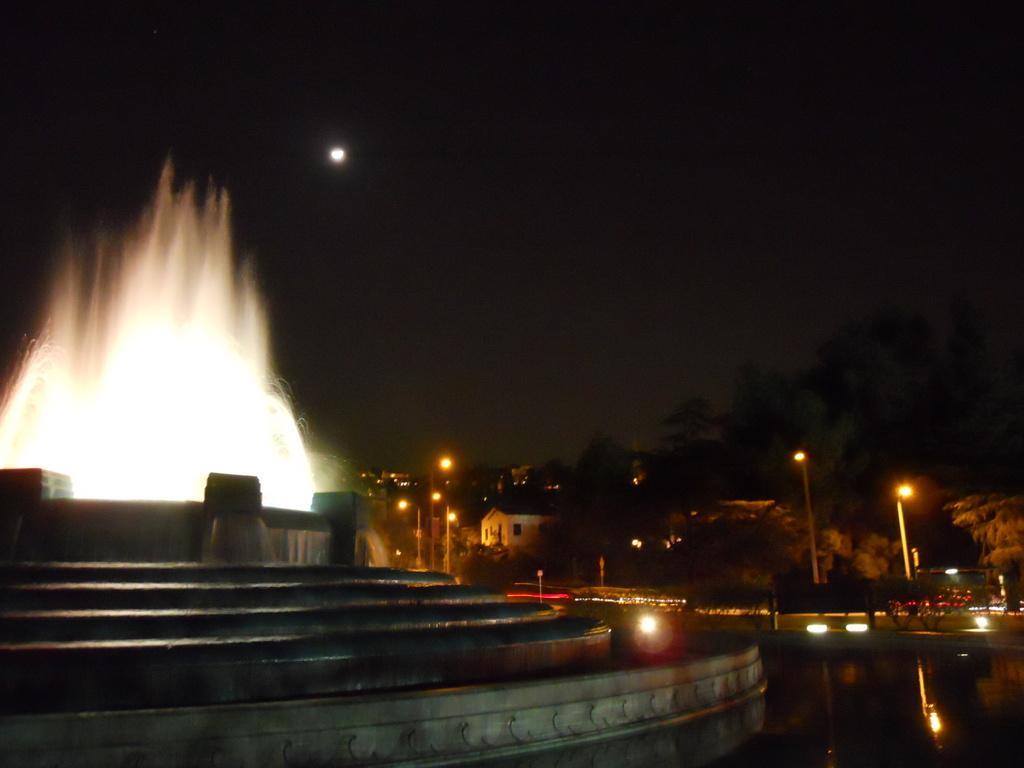How would you summarize this image in a sentence or two? In this image there are trees, buildings and in the center there is a water fountain and there are steps and we can see moon in the sky. 